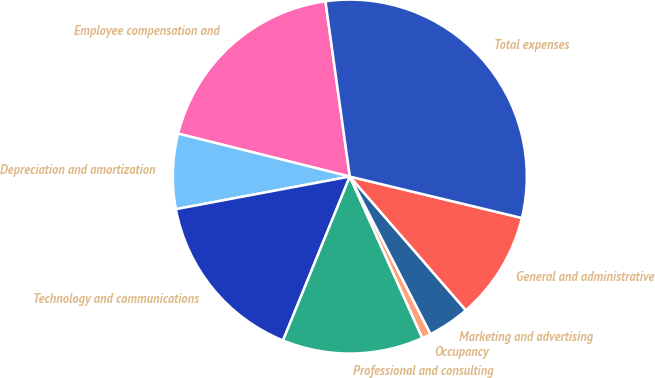Convert chart. <chart><loc_0><loc_0><loc_500><loc_500><pie_chart><fcel>Employee compensation and<fcel>Depreciation and amortization<fcel>Technology and communications<fcel>Professional and consulting<fcel>Occupancy<fcel>Marketing and advertising<fcel>General and administrative<fcel>Total expenses<nl><fcel>18.9%<fcel>6.85%<fcel>15.89%<fcel>12.88%<fcel>0.82%<fcel>3.84%<fcel>9.86%<fcel>30.96%<nl></chart> 